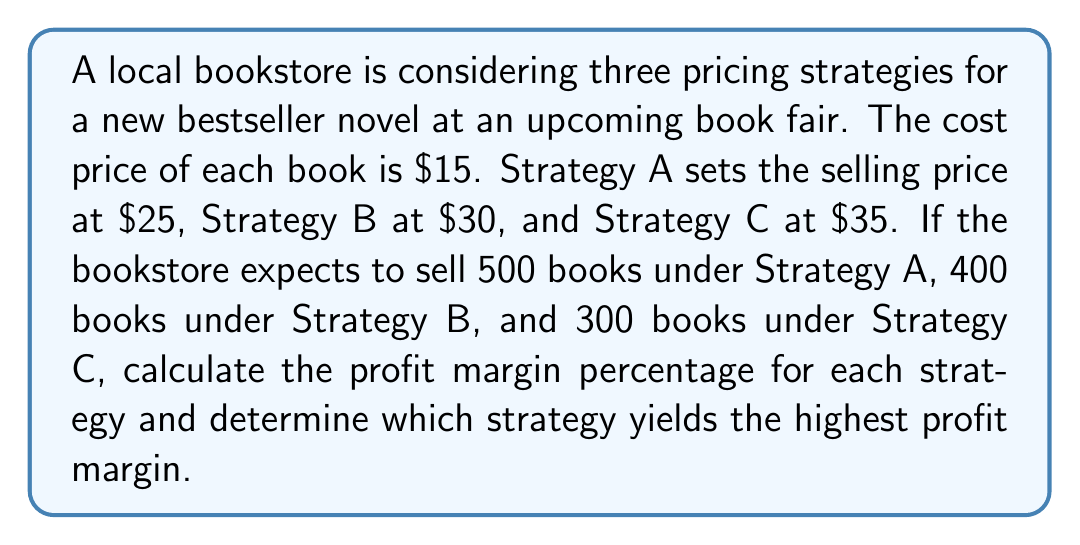Can you answer this question? Let's approach this step-by-step:

1) First, we need to calculate the profit per book for each strategy:
   Strategy A: $25 - $15 = $10 profit per book
   Strategy B: $30 - $15 = $15 profit per book
   Strategy C: $35 - $15 = $20 profit per book

2) Now, let's calculate the total profit for each strategy:
   Strategy A: $10 × 500 = $5,000
   Strategy B: $15 × 400 = $6,000
   Strategy C: $20 × 300 = $6,000

3) To calculate the profit margin percentage, we use the formula:
   $$ \text{Profit Margin} = \frac{\text{Profit}}{\text{Revenue}} \times 100\% $$

4) For Strategy A:
   Revenue = $25 × 500 = $12,500
   $$ \text{Profit Margin A} = \frac{5000}{12500} \times 100\% = 40\% $$

5) For Strategy B:
   Revenue = $30 × 400 = $12,000
   $$ \text{Profit Margin B} = \frac{6000}{12000} \times 100\% = 50\% $$

6) For Strategy C:
   Revenue = $35 × 300 = $10,500
   $$ \text{Profit Margin C} = \frac{6000}{10500} \times 100\% \approx 57.14\% $$

Therefore, Strategy C yields the highest profit margin percentage.
Answer: Strategy A: 40%, Strategy B: 50%, Strategy C: 57.14%. Strategy C yields the highest profit margin. 